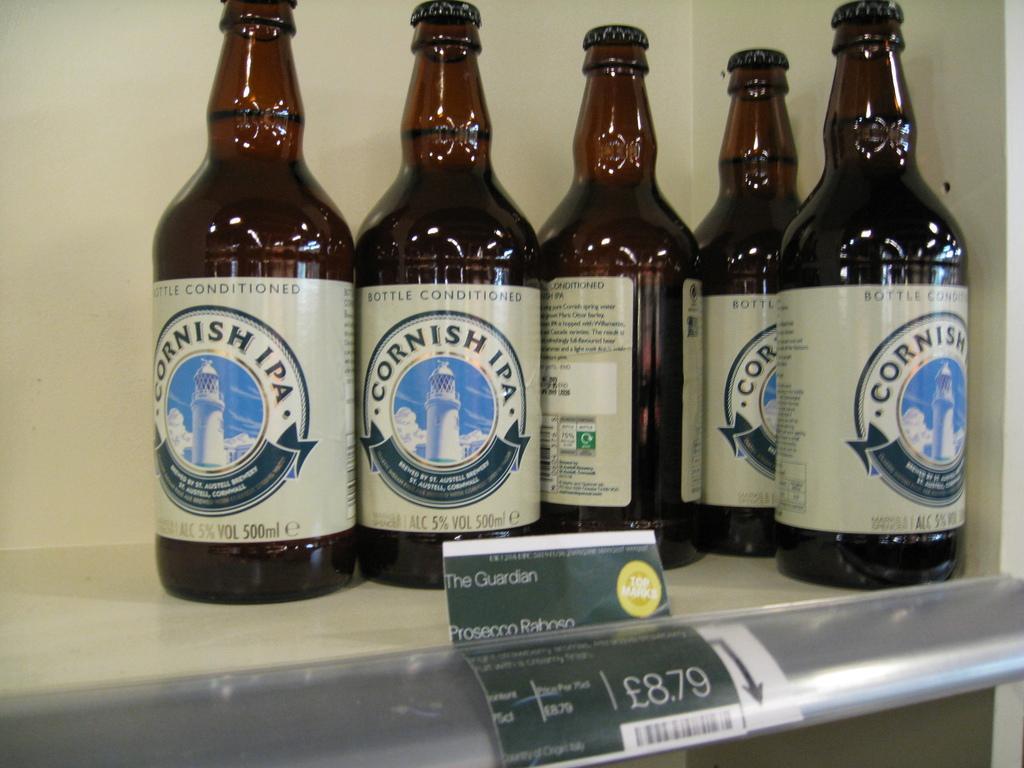Could you give a brief overview of what you see in this image? In this image there are five bottles. 